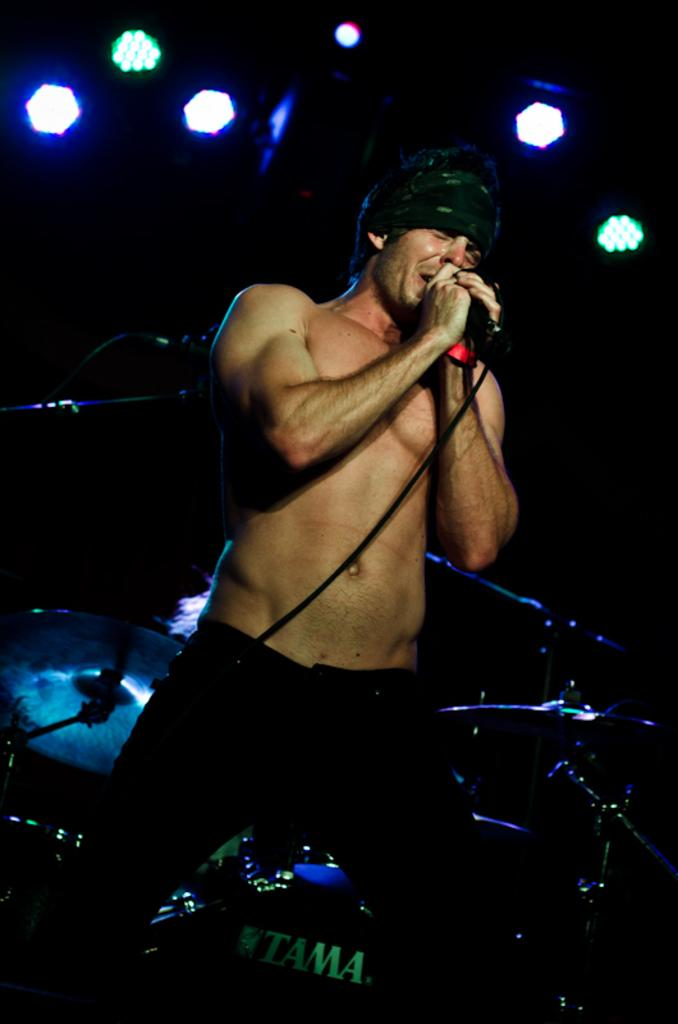What is the man in the image doing? The man is standing and singing in the image. What is the man holding while singing? The man is holding a microphone. What can be seen in the background of the image? There are lights visible in the background. How does the man's growth rate change after the performance in the image? There is no information about the man's growth rate or any performance in the image, so it cannot be determined. 